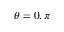Convert formula to latex. <formula><loc_0><loc_0><loc_500><loc_500>\theta = 0 , \pi</formula> 